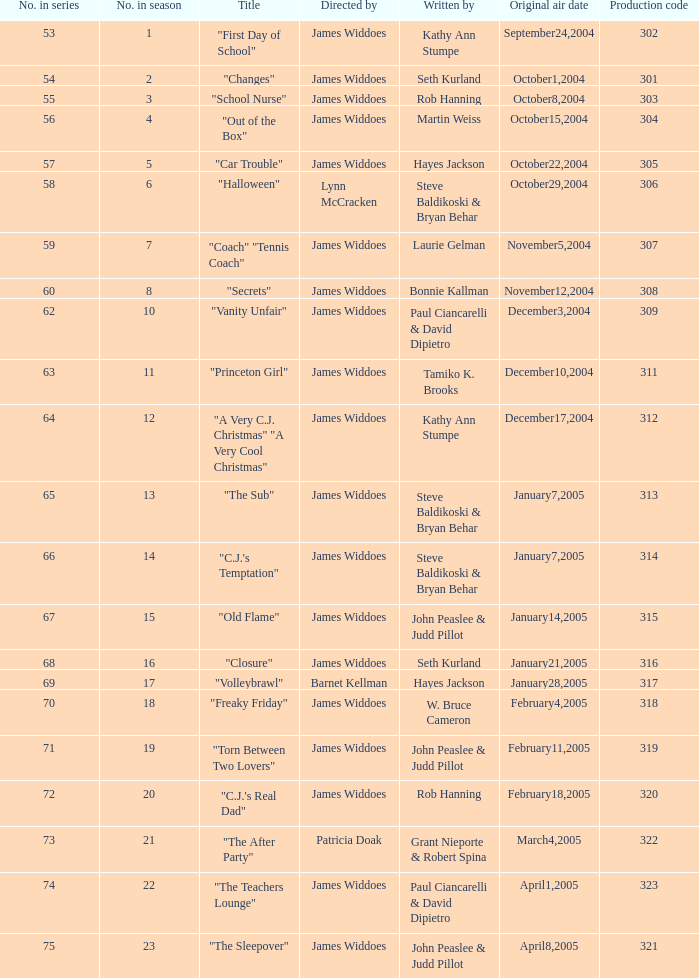Who directed "Freaky Friday"? James Widdoes. 